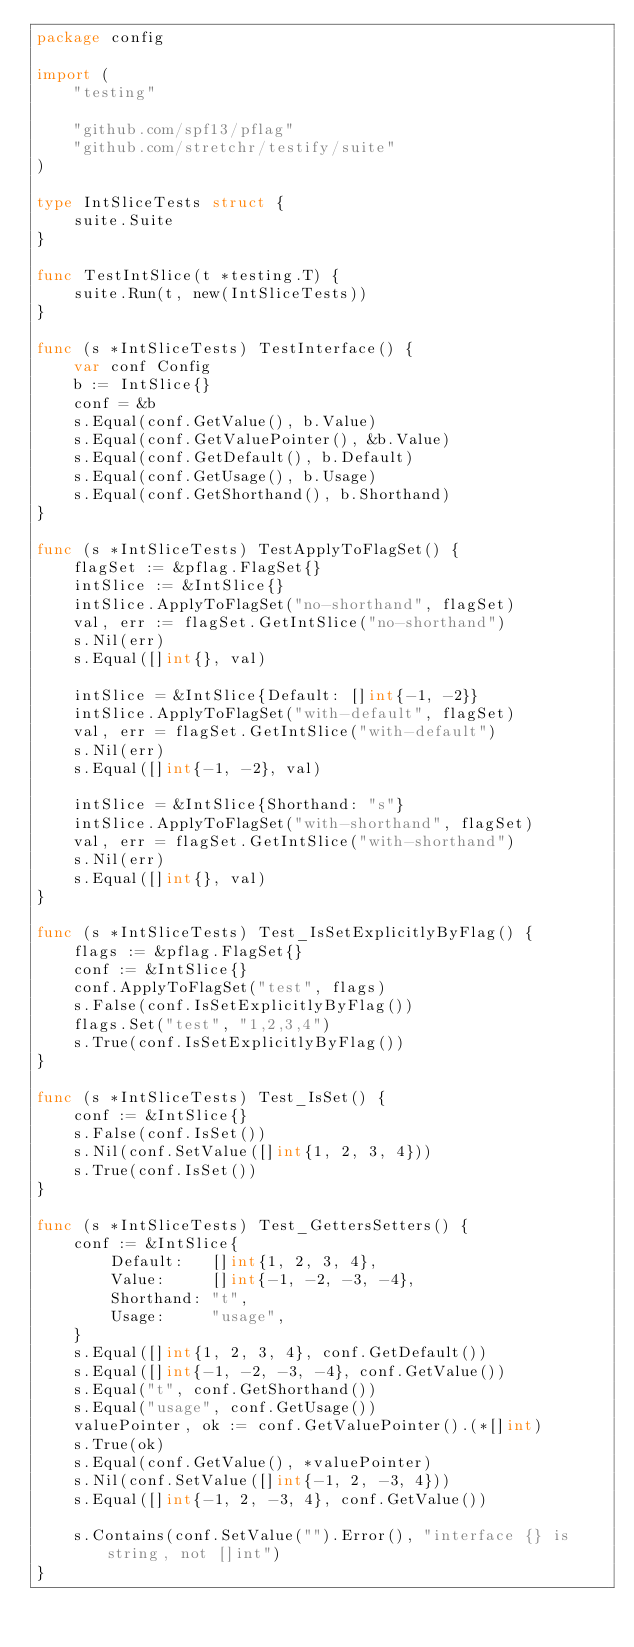<code> <loc_0><loc_0><loc_500><loc_500><_Go_>package config

import (
	"testing"

	"github.com/spf13/pflag"
	"github.com/stretchr/testify/suite"
)

type IntSliceTests struct {
	suite.Suite
}

func TestIntSlice(t *testing.T) {
	suite.Run(t, new(IntSliceTests))
}

func (s *IntSliceTests) TestInterface() {
	var conf Config
	b := IntSlice{}
	conf = &b
	s.Equal(conf.GetValue(), b.Value)
	s.Equal(conf.GetValuePointer(), &b.Value)
	s.Equal(conf.GetDefault(), b.Default)
	s.Equal(conf.GetUsage(), b.Usage)
	s.Equal(conf.GetShorthand(), b.Shorthand)
}

func (s *IntSliceTests) TestApplyToFlagSet() {
	flagSet := &pflag.FlagSet{}
	intSlice := &IntSlice{}
	intSlice.ApplyToFlagSet("no-shorthand", flagSet)
	val, err := flagSet.GetIntSlice("no-shorthand")
	s.Nil(err)
	s.Equal([]int{}, val)

	intSlice = &IntSlice{Default: []int{-1, -2}}
	intSlice.ApplyToFlagSet("with-default", flagSet)
	val, err = flagSet.GetIntSlice("with-default")
	s.Nil(err)
	s.Equal([]int{-1, -2}, val)

	intSlice = &IntSlice{Shorthand: "s"}
	intSlice.ApplyToFlagSet("with-shorthand", flagSet)
	val, err = flagSet.GetIntSlice("with-shorthand")
	s.Nil(err)
	s.Equal([]int{}, val)
}

func (s *IntSliceTests) Test_IsSetExplicitlyByFlag() {
	flags := &pflag.FlagSet{}
	conf := &IntSlice{}
	conf.ApplyToFlagSet("test", flags)
	s.False(conf.IsSetExplicitlyByFlag())
	flags.Set("test", "1,2,3,4")
	s.True(conf.IsSetExplicitlyByFlag())
}

func (s *IntSliceTests) Test_IsSet() {
	conf := &IntSlice{}
	s.False(conf.IsSet())
	s.Nil(conf.SetValue([]int{1, 2, 3, 4}))
	s.True(conf.IsSet())
}

func (s *IntSliceTests) Test_GettersSetters() {
	conf := &IntSlice{
		Default:   []int{1, 2, 3, 4},
		Value:     []int{-1, -2, -3, -4},
		Shorthand: "t",
		Usage:     "usage",
	}
	s.Equal([]int{1, 2, 3, 4}, conf.GetDefault())
	s.Equal([]int{-1, -2, -3, -4}, conf.GetValue())
	s.Equal("t", conf.GetShorthand())
	s.Equal("usage", conf.GetUsage())
	valuePointer, ok := conf.GetValuePointer().(*[]int)
	s.True(ok)
	s.Equal(conf.GetValue(), *valuePointer)
	s.Nil(conf.SetValue([]int{-1, 2, -3, 4}))
	s.Equal([]int{-1, 2, -3, 4}, conf.GetValue())

	s.Contains(conf.SetValue("").Error(), "interface {} is string, not []int")
}
</code> 